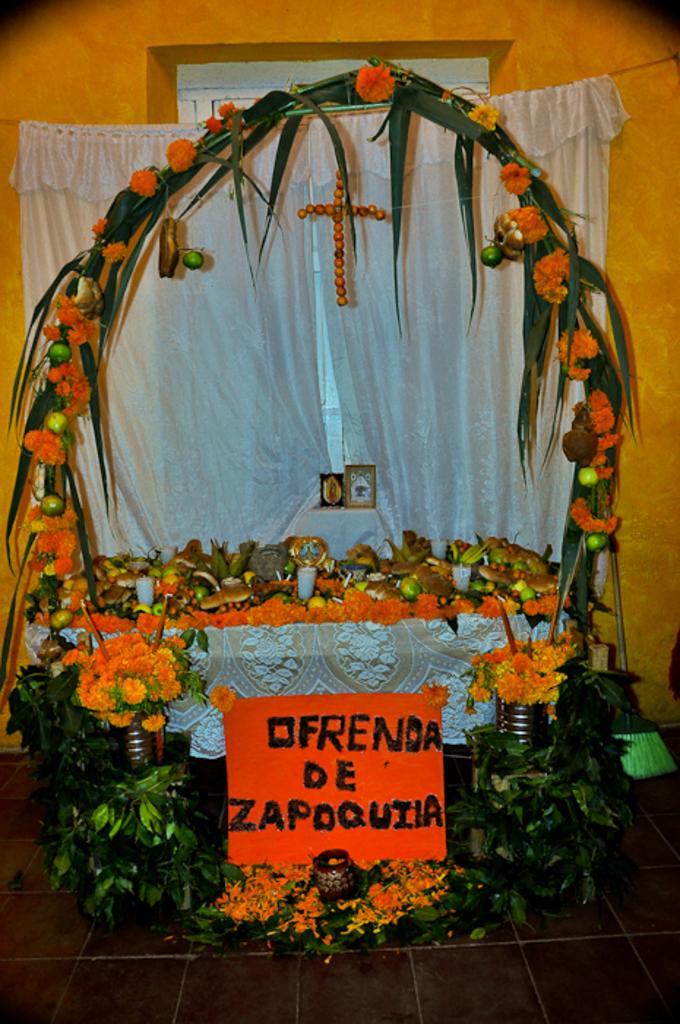How would you summarize this image in a sentence or two? There are flowers and a board at the bottom of this image and we can see a white color curtain and a wall in the background. 